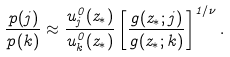<formula> <loc_0><loc_0><loc_500><loc_500>\frac { p ( j ) } { p ( k ) } \approx \frac { u _ { j } ^ { 0 } ( z _ { * } ) } { u _ { k } ^ { 0 } ( z _ { * } ) } \left [ \frac { g ( z _ { * } ; j ) } { g ( z _ { * } ; k ) } \right ] ^ { 1 / \nu } .</formula> 